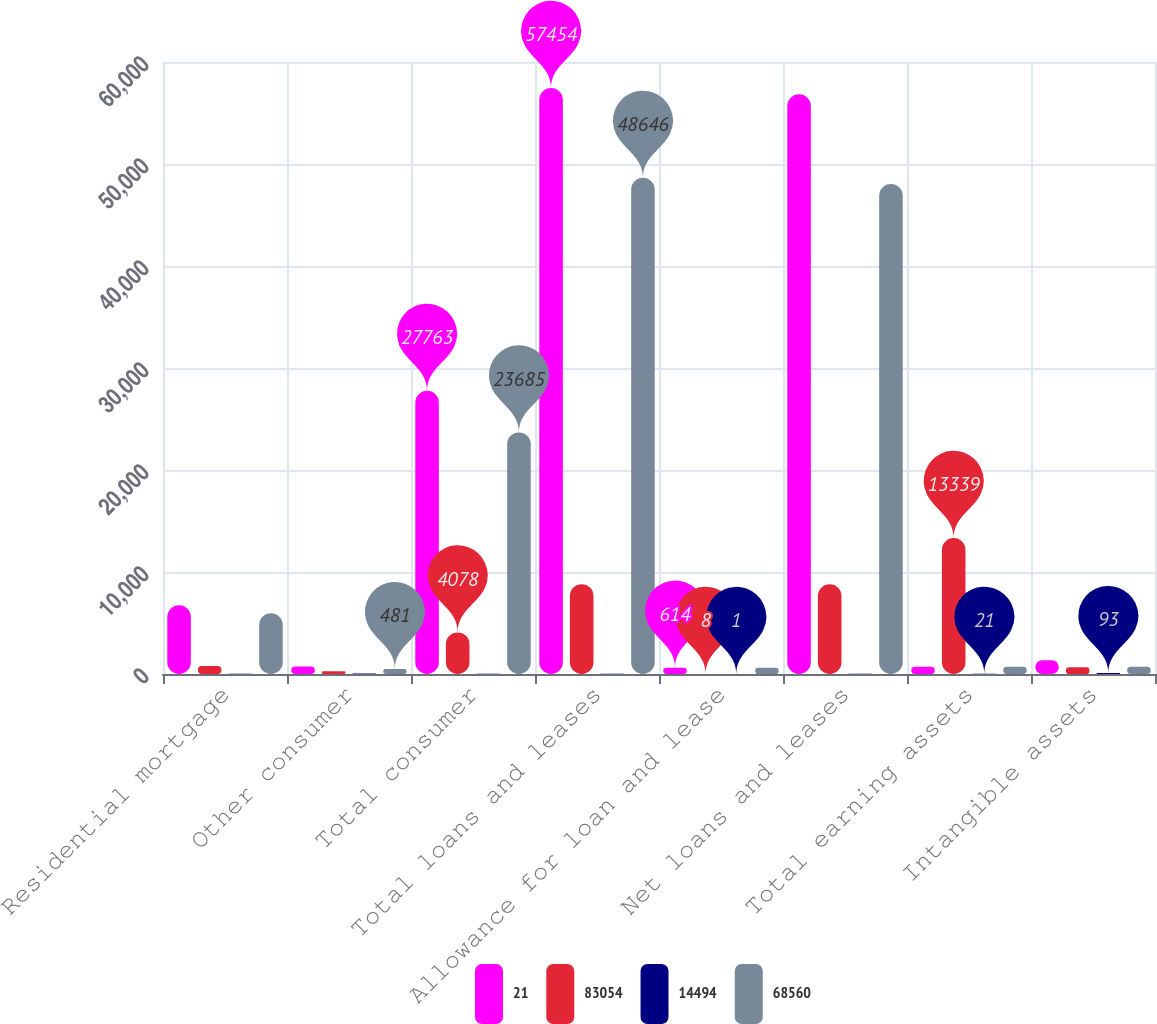Convert chart. <chart><loc_0><loc_0><loc_500><loc_500><stacked_bar_chart><ecel><fcel>Residential mortgage<fcel>Other consumer<fcel>Total consumer<fcel>Total loans and leases<fcel>Allowance for loan and lease<fcel>Net loans and leases<fcel>Total earning assets<fcel>Intangible assets<nl><fcel>21<fcel>6730<fcel>742<fcel>27763<fcel>57454<fcel>614<fcel>56840<fcel>722.5<fcel>1359<nl><fcel>83054<fcel>780<fcel>261<fcel>4078<fcel>8808<fcel>8<fcel>8800<fcel>13339<fcel>656<nl><fcel>14494<fcel>13<fcel>54<fcel>17<fcel>18<fcel>1<fcel>18<fcel>21<fcel>93<nl><fcel>68560<fcel>5950<fcel>481<fcel>23685<fcel>48646<fcel>606<fcel>48040<fcel>722.5<fcel>703<nl></chart> 